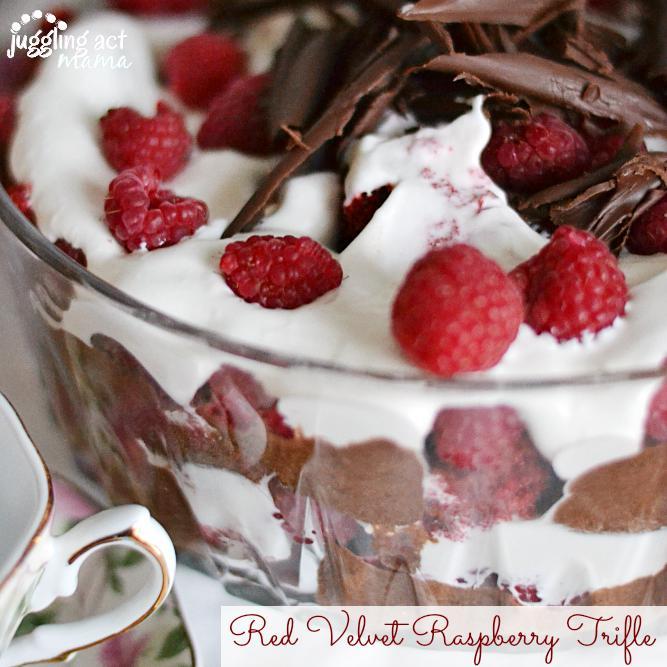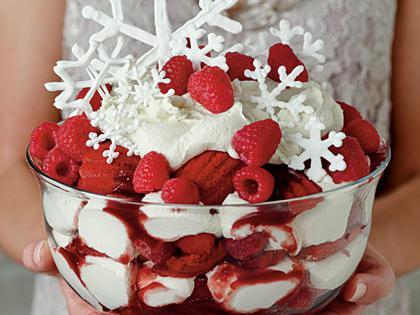The first image is the image on the left, the second image is the image on the right. For the images displayed, is the sentence "Whole red raspberries garnish the top of at least one layered dessert served in a clear glass dish." factually correct? Answer yes or no. Yes. The first image is the image on the left, the second image is the image on the right. Considering the images on both sides, is "Each dessert is being served in a large glass family sized portion." valid? Answer yes or no. Yes. 